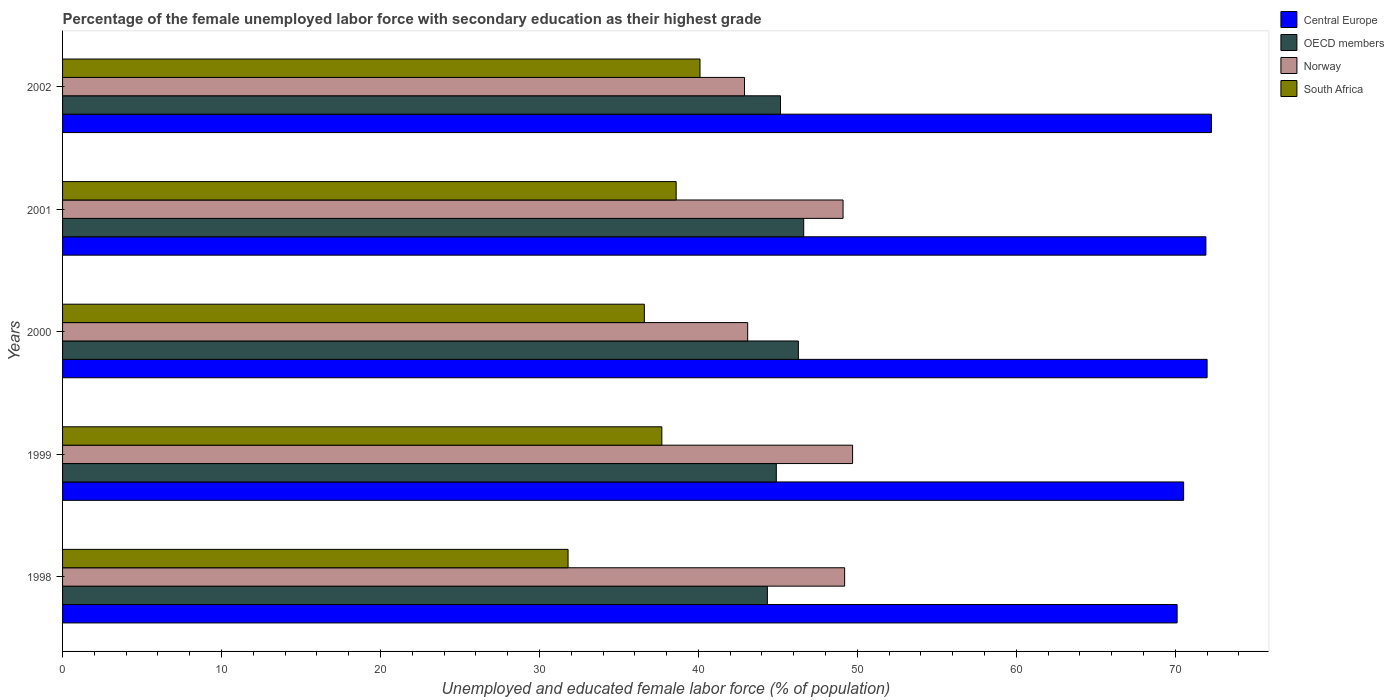How many different coloured bars are there?
Your answer should be compact. 4. How many groups of bars are there?
Offer a terse response. 5. Are the number of bars per tick equal to the number of legend labels?
Offer a terse response. Yes. How many bars are there on the 2nd tick from the top?
Offer a terse response. 4. What is the percentage of the unemployed female labor force with secondary education in Norway in 1999?
Keep it short and to the point. 49.7. Across all years, what is the maximum percentage of the unemployed female labor force with secondary education in Norway?
Keep it short and to the point. 49.7. Across all years, what is the minimum percentage of the unemployed female labor force with secondary education in South Africa?
Your answer should be very brief. 31.8. What is the total percentage of the unemployed female labor force with secondary education in Norway in the graph?
Your answer should be compact. 234. What is the difference between the percentage of the unemployed female labor force with secondary education in Central Europe in 1998 and that in 2002?
Keep it short and to the point. -2.16. What is the difference between the percentage of the unemployed female labor force with secondary education in Central Europe in 2001 and the percentage of the unemployed female labor force with secondary education in Norway in 2002?
Ensure brevity in your answer.  29.03. What is the average percentage of the unemployed female labor force with secondary education in Central Europe per year?
Make the answer very short. 71.37. In the year 1998, what is the difference between the percentage of the unemployed female labor force with secondary education in Norway and percentage of the unemployed female labor force with secondary education in Central Europe?
Your answer should be compact. -20.92. What is the ratio of the percentage of the unemployed female labor force with secondary education in South Africa in 1998 to that in 2002?
Give a very brief answer. 0.79. Is the percentage of the unemployed female labor force with secondary education in South Africa in 2000 less than that in 2002?
Provide a short and direct response. Yes. What is the difference between the highest and the second highest percentage of the unemployed female labor force with secondary education in Central Europe?
Give a very brief answer. 0.27. What is the difference between the highest and the lowest percentage of the unemployed female labor force with secondary education in OECD members?
Ensure brevity in your answer.  2.29. Is the sum of the percentage of the unemployed female labor force with secondary education in Norway in 1998 and 2002 greater than the maximum percentage of the unemployed female labor force with secondary education in OECD members across all years?
Your response must be concise. Yes. Is it the case that in every year, the sum of the percentage of the unemployed female labor force with secondary education in OECD members and percentage of the unemployed female labor force with secondary education in Norway is greater than the sum of percentage of the unemployed female labor force with secondary education in Central Europe and percentage of the unemployed female labor force with secondary education in South Africa?
Give a very brief answer. No. What does the 4th bar from the bottom in 1998 represents?
Provide a short and direct response. South Africa. Is it the case that in every year, the sum of the percentage of the unemployed female labor force with secondary education in OECD members and percentage of the unemployed female labor force with secondary education in Central Europe is greater than the percentage of the unemployed female labor force with secondary education in South Africa?
Offer a very short reply. Yes. Does the graph contain any zero values?
Your answer should be very brief. No. Does the graph contain grids?
Your response must be concise. No. How are the legend labels stacked?
Provide a succinct answer. Vertical. What is the title of the graph?
Offer a very short reply. Percentage of the female unemployed labor force with secondary education as their highest grade. What is the label or title of the X-axis?
Your answer should be compact. Unemployed and educated female labor force (% of population). What is the label or title of the Y-axis?
Make the answer very short. Years. What is the Unemployed and educated female labor force (% of population) of Central Europe in 1998?
Keep it short and to the point. 70.12. What is the Unemployed and educated female labor force (% of population) in OECD members in 1998?
Provide a short and direct response. 44.34. What is the Unemployed and educated female labor force (% of population) in Norway in 1998?
Your answer should be very brief. 49.2. What is the Unemployed and educated female labor force (% of population) of South Africa in 1998?
Ensure brevity in your answer.  31.8. What is the Unemployed and educated female labor force (% of population) in Central Europe in 1999?
Make the answer very short. 70.52. What is the Unemployed and educated female labor force (% of population) of OECD members in 1999?
Keep it short and to the point. 44.9. What is the Unemployed and educated female labor force (% of population) of Norway in 1999?
Your response must be concise. 49.7. What is the Unemployed and educated female labor force (% of population) in South Africa in 1999?
Offer a very short reply. 37.7. What is the Unemployed and educated female labor force (% of population) in Central Europe in 2000?
Your answer should be compact. 72. What is the Unemployed and educated female labor force (% of population) in OECD members in 2000?
Your response must be concise. 46.29. What is the Unemployed and educated female labor force (% of population) of Norway in 2000?
Your answer should be compact. 43.1. What is the Unemployed and educated female labor force (% of population) of South Africa in 2000?
Ensure brevity in your answer.  36.6. What is the Unemployed and educated female labor force (% of population) in Central Europe in 2001?
Ensure brevity in your answer.  71.93. What is the Unemployed and educated female labor force (% of population) of OECD members in 2001?
Keep it short and to the point. 46.63. What is the Unemployed and educated female labor force (% of population) of Norway in 2001?
Provide a short and direct response. 49.1. What is the Unemployed and educated female labor force (% of population) of South Africa in 2001?
Give a very brief answer. 38.6. What is the Unemployed and educated female labor force (% of population) in Central Europe in 2002?
Provide a short and direct response. 72.28. What is the Unemployed and educated female labor force (% of population) in OECD members in 2002?
Provide a succinct answer. 45.16. What is the Unemployed and educated female labor force (% of population) of Norway in 2002?
Provide a succinct answer. 42.9. What is the Unemployed and educated female labor force (% of population) of South Africa in 2002?
Make the answer very short. 40.1. Across all years, what is the maximum Unemployed and educated female labor force (% of population) in Central Europe?
Make the answer very short. 72.28. Across all years, what is the maximum Unemployed and educated female labor force (% of population) of OECD members?
Your answer should be compact. 46.63. Across all years, what is the maximum Unemployed and educated female labor force (% of population) of Norway?
Provide a short and direct response. 49.7. Across all years, what is the maximum Unemployed and educated female labor force (% of population) in South Africa?
Keep it short and to the point. 40.1. Across all years, what is the minimum Unemployed and educated female labor force (% of population) of Central Europe?
Offer a terse response. 70.12. Across all years, what is the minimum Unemployed and educated female labor force (% of population) in OECD members?
Offer a terse response. 44.34. Across all years, what is the minimum Unemployed and educated female labor force (% of population) of Norway?
Make the answer very short. 42.9. Across all years, what is the minimum Unemployed and educated female labor force (% of population) in South Africa?
Ensure brevity in your answer.  31.8. What is the total Unemployed and educated female labor force (% of population) of Central Europe in the graph?
Your response must be concise. 356.84. What is the total Unemployed and educated female labor force (% of population) in OECD members in the graph?
Provide a short and direct response. 227.32. What is the total Unemployed and educated female labor force (% of population) of Norway in the graph?
Your answer should be compact. 234. What is the total Unemployed and educated female labor force (% of population) of South Africa in the graph?
Give a very brief answer. 184.8. What is the difference between the Unemployed and educated female labor force (% of population) of Central Europe in 1998 and that in 1999?
Your response must be concise. -0.41. What is the difference between the Unemployed and educated female labor force (% of population) of OECD members in 1998 and that in 1999?
Your answer should be compact. -0.56. What is the difference between the Unemployed and educated female labor force (% of population) of Norway in 1998 and that in 1999?
Your answer should be compact. -0.5. What is the difference between the Unemployed and educated female labor force (% of population) in South Africa in 1998 and that in 1999?
Offer a terse response. -5.9. What is the difference between the Unemployed and educated female labor force (% of population) of Central Europe in 1998 and that in 2000?
Your answer should be very brief. -1.89. What is the difference between the Unemployed and educated female labor force (% of population) in OECD members in 1998 and that in 2000?
Your response must be concise. -1.95. What is the difference between the Unemployed and educated female labor force (% of population) of South Africa in 1998 and that in 2000?
Give a very brief answer. -4.8. What is the difference between the Unemployed and educated female labor force (% of population) in Central Europe in 1998 and that in 2001?
Offer a terse response. -1.81. What is the difference between the Unemployed and educated female labor force (% of population) in OECD members in 1998 and that in 2001?
Make the answer very short. -2.29. What is the difference between the Unemployed and educated female labor force (% of population) of Norway in 1998 and that in 2001?
Provide a short and direct response. 0.1. What is the difference between the Unemployed and educated female labor force (% of population) in South Africa in 1998 and that in 2001?
Give a very brief answer. -6.8. What is the difference between the Unemployed and educated female labor force (% of population) of Central Europe in 1998 and that in 2002?
Ensure brevity in your answer.  -2.16. What is the difference between the Unemployed and educated female labor force (% of population) of OECD members in 1998 and that in 2002?
Ensure brevity in your answer.  -0.83. What is the difference between the Unemployed and educated female labor force (% of population) in South Africa in 1998 and that in 2002?
Offer a very short reply. -8.3. What is the difference between the Unemployed and educated female labor force (% of population) in Central Europe in 1999 and that in 2000?
Keep it short and to the point. -1.48. What is the difference between the Unemployed and educated female labor force (% of population) in OECD members in 1999 and that in 2000?
Your answer should be compact. -1.39. What is the difference between the Unemployed and educated female labor force (% of population) of Norway in 1999 and that in 2000?
Provide a succinct answer. 6.6. What is the difference between the Unemployed and educated female labor force (% of population) in South Africa in 1999 and that in 2000?
Keep it short and to the point. 1.1. What is the difference between the Unemployed and educated female labor force (% of population) in Central Europe in 1999 and that in 2001?
Your answer should be very brief. -1.4. What is the difference between the Unemployed and educated female labor force (% of population) of OECD members in 1999 and that in 2001?
Offer a very short reply. -1.72. What is the difference between the Unemployed and educated female labor force (% of population) of Norway in 1999 and that in 2001?
Provide a succinct answer. 0.6. What is the difference between the Unemployed and educated female labor force (% of population) in Central Europe in 1999 and that in 2002?
Your answer should be compact. -1.75. What is the difference between the Unemployed and educated female labor force (% of population) of OECD members in 1999 and that in 2002?
Offer a very short reply. -0.26. What is the difference between the Unemployed and educated female labor force (% of population) of South Africa in 1999 and that in 2002?
Ensure brevity in your answer.  -2.4. What is the difference between the Unemployed and educated female labor force (% of population) in Central Europe in 2000 and that in 2001?
Your answer should be very brief. 0.08. What is the difference between the Unemployed and educated female labor force (% of population) in OECD members in 2000 and that in 2001?
Give a very brief answer. -0.34. What is the difference between the Unemployed and educated female labor force (% of population) in South Africa in 2000 and that in 2001?
Your answer should be very brief. -2. What is the difference between the Unemployed and educated female labor force (% of population) in Central Europe in 2000 and that in 2002?
Your answer should be compact. -0.27. What is the difference between the Unemployed and educated female labor force (% of population) of OECD members in 2000 and that in 2002?
Offer a terse response. 1.12. What is the difference between the Unemployed and educated female labor force (% of population) in Norway in 2000 and that in 2002?
Offer a very short reply. 0.2. What is the difference between the Unemployed and educated female labor force (% of population) in Central Europe in 2001 and that in 2002?
Keep it short and to the point. -0.35. What is the difference between the Unemployed and educated female labor force (% of population) in OECD members in 2001 and that in 2002?
Give a very brief answer. 1.46. What is the difference between the Unemployed and educated female labor force (% of population) in Norway in 2001 and that in 2002?
Ensure brevity in your answer.  6.2. What is the difference between the Unemployed and educated female labor force (% of population) of Central Europe in 1998 and the Unemployed and educated female labor force (% of population) of OECD members in 1999?
Provide a short and direct response. 25.22. What is the difference between the Unemployed and educated female labor force (% of population) of Central Europe in 1998 and the Unemployed and educated female labor force (% of population) of Norway in 1999?
Ensure brevity in your answer.  20.42. What is the difference between the Unemployed and educated female labor force (% of population) in Central Europe in 1998 and the Unemployed and educated female labor force (% of population) in South Africa in 1999?
Ensure brevity in your answer.  32.42. What is the difference between the Unemployed and educated female labor force (% of population) of OECD members in 1998 and the Unemployed and educated female labor force (% of population) of Norway in 1999?
Ensure brevity in your answer.  -5.36. What is the difference between the Unemployed and educated female labor force (% of population) in OECD members in 1998 and the Unemployed and educated female labor force (% of population) in South Africa in 1999?
Your answer should be compact. 6.64. What is the difference between the Unemployed and educated female labor force (% of population) in Central Europe in 1998 and the Unemployed and educated female labor force (% of population) in OECD members in 2000?
Give a very brief answer. 23.83. What is the difference between the Unemployed and educated female labor force (% of population) of Central Europe in 1998 and the Unemployed and educated female labor force (% of population) of Norway in 2000?
Your answer should be compact. 27.02. What is the difference between the Unemployed and educated female labor force (% of population) in Central Europe in 1998 and the Unemployed and educated female labor force (% of population) in South Africa in 2000?
Provide a short and direct response. 33.52. What is the difference between the Unemployed and educated female labor force (% of population) of OECD members in 1998 and the Unemployed and educated female labor force (% of population) of Norway in 2000?
Provide a succinct answer. 1.24. What is the difference between the Unemployed and educated female labor force (% of population) in OECD members in 1998 and the Unemployed and educated female labor force (% of population) in South Africa in 2000?
Provide a succinct answer. 7.74. What is the difference between the Unemployed and educated female labor force (% of population) of Norway in 1998 and the Unemployed and educated female labor force (% of population) of South Africa in 2000?
Provide a short and direct response. 12.6. What is the difference between the Unemployed and educated female labor force (% of population) of Central Europe in 1998 and the Unemployed and educated female labor force (% of population) of OECD members in 2001?
Offer a terse response. 23.49. What is the difference between the Unemployed and educated female labor force (% of population) in Central Europe in 1998 and the Unemployed and educated female labor force (% of population) in Norway in 2001?
Your answer should be compact. 21.02. What is the difference between the Unemployed and educated female labor force (% of population) of Central Europe in 1998 and the Unemployed and educated female labor force (% of population) of South Africa in 2001?
Offer a very short reply. 31.52. What is the difference between the Unemployed and educated female labor force (% of population) of OECD members in 1998 and the Unemployed and educated female labor force (% of population) of Norway in 2001?
Your answer should be compact. -4.76. What is the difference between the Unemployed and educated female labor force (% of population) of OECD members in 1998 and the Unemployed and educated female labor force (% of population) of South Africa in 2001?
Your answer should be compact. 5.74. What is the difference between the Unemployed and educated female labor force (% of population) of Central Europe in 1998 and the Unemployed and educated female labor force (% of population) of OECD members in 2002?
Give a very brief answer. 24.95. What is the difference between the Unemployed and educated female labor force (% of population) of Central Europe in 1998 and the Unemployed and educated female labor force (% of population) of Norway in 2002?
Keep it short and to the point. 27.22. What is the difference between the Unemployed and educated female labor force (% of population) in Central Europe in 1998 and the Unemployed and educated female labor force (% of population) in South Africa in 2002?
Keep it short and to the point. 30.02. What is the difference between the Unemployed and educated female labor force (% of population) of OECD members in 1998 and the Unemployed and educated female labor force (% of population) of Norway in 2002?
Provide a succinct answer. 1.44. What is the difference between the Unemployed and educated female labor force (% of population) in OECD members in 1998 and the Unemployed and educated female labor force (% of population) in South Africa in 2002?
Offer a very short reply. 4.24. What is the difference between the Unemployed and educated female labor force (% of population) of Norway in 1998 and the Unemployed and educated female labor force (% of population) of South Africa in 2002?
Offer a terse response. 9.1. What is the difference between the Unemployed and educated female labor force (% of population) of Central Europe in 1999 and the Unemployed and educated female labor force (% of population) of OECD members in 2000?
Offer a terse response. 24.24. What is the difference between the Unemployed and educated female labor force (% of population) of Central Europe in 1999 and the Unemployed and educated female labor force (% of population) of Norway in 2000?
Your response must be concise. 27.42. What is the difference between the Unemployed and educated female labor force (% of population) of Central Europe in 1999 and the Unemployed and educated female labor force (% of population) of South Africa in 2000?
Give a very brief answer. 33.92. What is the difference between the Unemployed and educated female labor force (% of population) of OECD members in 1999 and the Unemployed and educated female labor force (% of population) of Norway in 2000?
Provide a short and direct response. 1.8. What is the difference between the Unemployed and educated female labor force (% of population) in OECD members in 1999 and the Unemployed and educated female labor force (% of population) in South Africa in 2000?
Provide a succinct answer. 8.3. What is the difference between the Unemployed and educated female labor force (% of population) of Norway in 1999 and the Unemployed and educated female labor force (% of population) of South Africa in 2000?
Your answer should be very brief. 13.1. What is the difference between the Unemployed and educated female labor force (% of population) of Central Europe in 1999 and the Unemployed and educated female labor force (% of population) of OECD members in 2001?
Your response must be concise. 23.9. What is the difference between the Unemployed and educated female labor force (% of population) in Central Europe in 1999 and the Unemployed and educated female labor force (% of population) in Norway in 2001?
Provide a succinct answer. 21.42. What is the difference between the Unemployed and educated female labor force (% of population) of Central Europe in 1999 and the Unemployed and educated female labor force (% of population) of South Africa in 2001?
Offer a terse response. 31.92. What is the difference between the Unemployed and educated female labor force (% of population) of OECD members in 1999 and the Unemployed and educated female labor force (% of population) of Norway in 2001?
Your answer should be compact. -4.2. What is the difference between the Unemployed and educated female labor force (% of population) in OECD members in 1999 and the Unemployed and educated female labor force (% of population) in South Africa in 2001?
Ensure brevity in your answer.  6.3. What is the difference between the Unemployed and educated female labor force (% of population) of Central Europe in 1999 and the Unemployed and educated female labor force (% of population) of OECD members in 2002?
Your response must be concise. 25.36. What is the difference between the Unemployed and educated female labor force (% of population) in Central Europe in 1999 and the Unemployed and educated female labor force (% of population) in Norway in 2002?
Provide a succinct answer. 27.62. What is the difference between the Unemployed and educated female labor force (% of population) in Central Europe in 1999 and the Unemployed and educated female labor force (% of population) in South Africa in 2002?
Offer a very short reply. 30.42. What is the difference between the Unemployed and educated female labor force (% of population) of OECD members in 1999 and the Unemployed and educated female labor force (% of population) of Norway in 2002?
Offer a terse response. 2. What is the difference between the Unemployed and educated female labor force (% of population) of OECD members in 1999 and the Unemployed and educated female labor force (% of population) of South Africa in 2002?
Your response must be concise. 4.8. What is the difference between the Unemployed and educated female labor force (% of population) of Central Europe in 2000 and the Unemployed and educated female labor force (% of population) of OECD members in 2001?
Ensure brevity in your answer.  25.38. What is the difference between the Unemployed and educated female labor force (% of population) in Central Europe in 2000 and the Unemployed and educated female labor force (% of population) in Norway in 2001?
Keep it short and to the point. 22.9. What is the difference between the Unemployed and educated female labor force (% of population) in Central Europe in 2000 and the Unemployed and educated female labor force (% of population) in South Africa in 2001?
Your answer should be very brief. 33.4. What is the difference between the Unemployed and educated female labor force (% of population) in OECD members in 2000 and the Unemployed and educated female labor force (% of population) in Norway in 2001?
Keep it short and to the point. -2.81. What is the difference between the Unemployed and educated female labor force (% of population) in OECD members in 2000 and the Unemployed and educated female labor force (% of population) in South Africa in 2001?
Keep it short and to the point. 7.69. What is the difference between the Unemployed and educated female labor force (% of population) in Norway in 2000 and the Unemployed and educated female labor force (% of population) in South Africa in 2001?
Offer a terse response. 4.5. What is the difference between the Unemployed and educated female labor force (% of population) in Central Europe in 2000 and the Unemployed and educated female labor force (% of population) in OECD members in 2002?
Your response must be concise. 26.84. What is the difference between the Unemployed and educated female labor force (% of population) in Central Europe in 2000 and the Unemployed and educated female labor force (% of population) in Norway in 2002?
Your answer should be compact. 29.1. What is the difference between the Unemployed and educated female labor force (% of population) in Central Europe in 2000 and the Unemployed and educated female labor force (% of population) in South Africa in 2002?
Your answer should be compact. 31.9. What is the difference between the Unemployed and educated female labor force (% of population) of OECD members in 2000 and the Unemployed and educated female labor force (% of population) of Norway in 2002?
Make the answer very short. 3.39. What is the difference between the Unemployed and educated female labor force (% of population) of OECD members in 2000 and the Unemployed and educated female labor force (% of population) of South Africa in 2002?
Offer a terse response. 6.19. What is the difference between the Unemployed and educated female labor force (% of population) of Norway in 2000 and the Unemployed and educated female labor force (% of population) of South Africa in 2002?
Provide a succinct answer. 3. What is the difference between the Unemployed and educated female labor force (% of population) in Central Europe in 2001 and the Unemployed and educated female labor force (% of population) in OECD members in 2002?
Ensure brevity in your answer.  26.76. What is the difference between the Unemployed and educated female labor force (% of population) of Central Europe in 2001 and the Unemployed and educated female labor force (% of population) of Norway in 2002?
Provide a short and direct response. 29.03. What is the difference between the Unemployed and educated female labor force (% of population) of Central Europe in 2001 and the Unemployed and educated female labor force (% of population) of South Africa in 2002?
Make the answer very short. 31.83. What is the difference between the Unemployed and educated female labor force (% of population) of OECD members in 2001 and the Unemployed and educated female labor force (% of population) of Norway in 2002?
Offer a terse response. 3.73. What is the difference between the Unemployed and educated female labor force (% of population) in OECD members in 2001 and the Unemployed and educated female labor force (% of population) in South Africa in 2002?
Provide a succinct answer. 6.53. What is the difference between the Unemployed and educated female labor force (% of population) of Norway in 2001 and the Unemployed and educated female labor force (% of population) of South Africa in 2002?
Provide a short and direct response. 9. What is the average Unemployed and educated female labor force (% of population) of Central Europe per year?
Provide a short and direct response. 71.37. What is the average Unemployed and educated female labor force (% of population) of OECD members per year?
Keep it short and to the point. 45.46. What is the average Unemployed and educated female labor force (% of population) of Norway per year?
Give a very brief answer. 46.8. What is the average Unemployed and educated female labor force (% of population) in South Africa per year?
Offer a terse response. 36.96. In the year 1998, what is the difference between the Unemployed and educated female labor force (% of population) of Central Europe and Unemployed and educated female labor force (% of population) of OECD members?
Offer a terse response. 25.78. In the year 1998, what is the difference between the Unemployed and educated female labor force (% of population) in Central Europe and Unemployed and educated female labor force (% of population) in Norway?
Provide a succinct answer. 20.92. In the year 1998, what is the difference between the Unemployed and educated female labor force (% of population) of Central Europe and Unemployed and educated female labor force (% of population) of South Africa?
Your response must be concise. 38.32. In the year 1998, what is the difference between the Unemployed and educated female labor force (% of population) of OECD members and Unemployed and educated female labor force (% of population) of Norway?
Your answer should be compact. -4.86. In the year 1998, what is the difference between the Unemployed and educated female labor force (% of population) of OECD members and Unemployed and educated female labor force (% of population) of South Africa?
Your answer should be very brief. 12.54. In the year 1998, what is the difference between the Unemployed and educated female labor force (% of population) in Norway and Unemployed and educated female labor force (% of population) in South Africa?
Offer a very short reply. 17.4. In the year 1999, what is the difference between the Unemployed and educated female labor force (% of population) of Central Europe and Unemployed and educated female labor force (% of population) of OECD members?
Offer a very short reply. 25.62. In the year 1999, what is the difference between the Unemployed and educated female labor force (% of population) in Central Europe and Unemployed and educated female labor force (% of population) in Norway?
Make the answer very short. 20.82. In the year 1999, what is the difference between the Unemployed and educated female labor force (% of population) of Central Europe and Unemployed and educated female labor force (% of population) of South Africa?
Ensure brevity in your answer.  32.82. In the year 1999, what is the difference between the Unemployed and educated female labor force (% of population) in OECD members and Unemployed and educated female labor force (% of population) in Norway?
Provide a short and direct response. -4.8. In the year 1999, what is the difference between the Unemployed and educated female labor force (% of population) of OECD members and Unemployed and educated female labor force (% of population) of South Africa?
Your answer should be very brief. 7.2. In the year 2000, what is the difference between the Unemployed and educated female labor force (% of population) in Central Europe and Unemployed and educated female labor force (% of population) in OECD members?
Provide a short and direct response. 25.71. In the year 2000, what is the difference between the Unemployed and educated female labor force (% of population) of Central Europe and Unemployed and educated female labor force (% of population) of Norway?
Give a very brief answer. 28.9. In the year 2000, what is the difference between the Unemployed and educated female labor force (% of population) of Central Europe and Unemployed and educated female labor force (% of population) of South Africa?
Provide a succinct answer. 35.4. In the year 2000, what is the difference between the Unemployed and educated female labor force (% of population) of OECD members and Unemployed and educated female labor force (% of population) of Norway?
Your response must be concise. 3.19. In the year 2000, what is the difference between the Unemployed and educated female labor force (% of population) of OECD members and Unemployed and educated female labor force (% of population) of South Africa?
Offer a very short reply. 9.69. In the year 2000, what is the difference between the Unemployed and educated female labor force (% of population) in Norway and Unemployed and educated female labor force (% of population) in South Africa?
Offer a terse response. 6.5. In the year 2001, what is the difference between the Unemployed and educated female labor force (% of population) of Central Europe and Unemployed and educated female labor force (% of population) of OECD members?
Your answer should be compact. 25.3. In the year 2001, what is the difference between the Unemployed and educated female labor force (% of population) in Central Europe and Unemployed and educated female labor force (% of population) in Norway?
Give a very brief answer. 22.83. In the year 2001, what is the difference between the Unemployed and educated female labor force (% of population) in Central Europe and Unemployed and educated female labor force (% of population) in South Africa?
Make the answer very short. 33.33. In the year 2001, what is the difference between the Unemployed and educated female labor force (% of population) of OECD members and Unemployed and educated female labor force (% of population) of Norway?
Provide a short and direct response. -2.47. In the year 2001, what is the difference between the Unemployed and educated female labor force (% of population) of OECD members and Unemployed and educated female labor force (% of population) of South Africa?
Make the answer very short. 8.03. In the year 2002, what is the difference between the Unemployed and educated female labor force (% of population) in Central Europe and Unemployed and educated female labor force (% of population) in OECD members?
Make the answer very short. 27.11. In the year 2002, what is the difference between the Unemployed and educated female labor force (% of population) in Central Europe and Unemployed and educated female labor force (% of population) in Norway?
Give a very brief answer. 29.38. In the year 2002, what is the difference between the Unemployed and educated female labor force (% of population) in Central Europe and Unemployed and educated female labor force (% of population) in South Africa?
Provide a succinct answer. 32.18. In the year 2002, what is the difference between the Unemployed and educated female labor force (% of population) of OECD members and Unemployed and educated female labor force (% of population) of Norway?
Provide a short and direct response. 2.26. In the year 2002, what is the difference between the Unemployed and educated female labor force (% of population) in OECD members and Unemployed and educated female labor force (% of population) in South Africa?
Make the answer very short. 5.06. In the year 2002, what is the difference between the Unemployed and educated female labor force (% of population) in Norway and Unemployed and educated female labor force (% of population) in South Africa?
Offer a terse response. 2.8. What is the ratio of the Unemployed and educated female labor force (% of population) of OECD members in 1998 to that in 1999?
Make the answer very short. 0.99. What is the ratio of the Unemployed and educated female labor force (% of population) in South Africa in 1998 to that in 1999?
Your response must be concise. 0.84. What is the ratio of the Unemployed and educated female labor force (% of population) in Central Europe in 1998 to that in 2000?
Offer a very short reply. 0.97. What is the ratio of the Unemployed and educated female labor force (% of population) in OECD members in 1998 to that in 2000?
Make the answer very short. 0.96. What is the ratio of the Unemployed and educated female labor force (% of population) in Norway in 1998 to that in 2000?
Your answer should be very brief. 1.14. What is the ratio of the Unemployed and educated female labor force (% of population) in South Africa in 1998 to that in 2000?
Offer a very short reply. 0.87. What is the ratio of the Unemployed and educated female labor force (% of population) in Central Europe in 1998 to that in 2001?
Offer a very short reply. 0.97. What is the ratio of the Unemployed and educated female labor force (% of population) of OECD members in 1998 to that in 2001?
Give a very brief answer. 0.95. What is the ratio of the Unemployed and educated female labor force (% of population) in South Africa in 1998 to that in 2001?
Provide a succinct answer. 0.82. What is the ratio of the Unemployed and educated female labor force (% of population) in Central Europe in 1998 to that in 2002?
Your response must be concise. 0.97. What is the ratio of the Unemployed and educated female labor force (% of population) of OECD members in 1998 to that in 2002?
Provide a succinct answer. 0.98. What is the ratio of the Unemployed and educated female labor force (% of population) of Norway in 1998 to that in 2002?
Offer a very short reply. 1.15. What is the ratio of the Unemployed and educated female labor force (% of population) of South Africa in 1998 to that in 2002?
Your answer should be very brief. 0.79. What is the ratio of the Unemployed and educated female labor force (% of population) in Central Europe in 1999 to that in 2000?
Make the answer very short. 0.98. What is the ratio of the Unemployed and educated female labor force (% of population) of Norway in 1999 to that in 2000?
Your answer should be very brief. 1.15. What is the ratio of the Unemployed and educated female labor force (% of population) in South Africa in 1999 to that in 2000?
Ensure brevity in your answer.  1.03. What is the ratio of the Unemployed and educated female labor force (% of population) in Central Europe in 1999 to that in 2001?
Make the answer very short. 0.98. What is the ratio of the Unemployed and educated female labor force (% of population) of Norway in 1999 to that in 2001?
Give a very brief answer. 1.01. What is the ratio of the Unemployed and educated female labor force (% of population) of South Africa in 1999 to that in 2001?
Give a very brief answer. 0.98. What is the ratio of the Unemployed and educated female labor force (% of population) in Central Europe in 1999 to that in 2002?
Offer a very short reply. 0.98. What is the ratio of the Unemployed and educated female labor force (% of population) of Norway in 1999 to that in 2002?
Offer a terse response. 1.16. What is the ratio of the Unemployed and educated female labor force (% of population) in South Africa in 1999 to that in 2002?
Your answer should be very brief. 0.94. What is the ratio of the Unemployed and educated female labor force (% of population) of OECD members in 2000 to that in 2001?
Provide a short and direct response. 0.99. What is the ratio of the Unemployed and educated female labor force (% of population) of Norway in 2000 to that in 2001?
Provide a short and direct response. 0.88. What is the ratio of the Unemployed and educated female labor force (% of population) of South Africa in 2000 to that in 2001?
Ensure brevity in your answer.  0.95. What is the ratio of the Unemployed and educated female labor force (% of population) of Central Europe in 2000 to that in 2002?
Provide a short and direct response. 1. What is the ratio of the Unemployed and educated female labor force (% of population) of OECD members in 2000 to that in 2002?
Your answer should be very brief. 1.02. What is the ratio of the Unemployed and educated female labor force (% of population) in South Africa in 2000 to that in 2002?
Offer a terse response. 0.91. What is the ratio of the Unemployed and educated female labor force (% of population) in Central Europe in 2001 to that in 2002?
Offer a very short reply. 1. What is the ratio of the Unemployed and educated female labor force (% of population) in OECD members in 2001 to that in 2002?
Keep it short and to the point. 1.03. What is the ratio of the Unemployed and educated female labor force (% of population) in Norway in 2001 to that in 2002?
Ensure brevity in your answer.  1.14. What is the ratio of the Unemployed and educated female labor force (% of population) of South Africa in 2001 to that in 2002?
Ensure brevity in your answer.  0.96. What is the difference between the highest and the second highest Unemployed and educated female labor force (% of population) of Central Europe?
Offer a very short reply. 0.27. What is the difference between the highest and the second highest Unemployed and educated female labor force (% of population) in OECD members?
Provide a short and direct response. 0.34. What is the difference between the highest and the second highest Unemployed and educated female labor force (% of population) of South Africa?
Offer a terse response. 1.5. What is the difference between the highest and the lowest Unemployed and educated female labor force (% of population) of Central Europe?
Provide a short and direct response. 2.16. What is the difference between the highest and the lowest Unemployed and educated female labor force (% of population) of OECD members?
Provide a short and direct response. 2.29. 